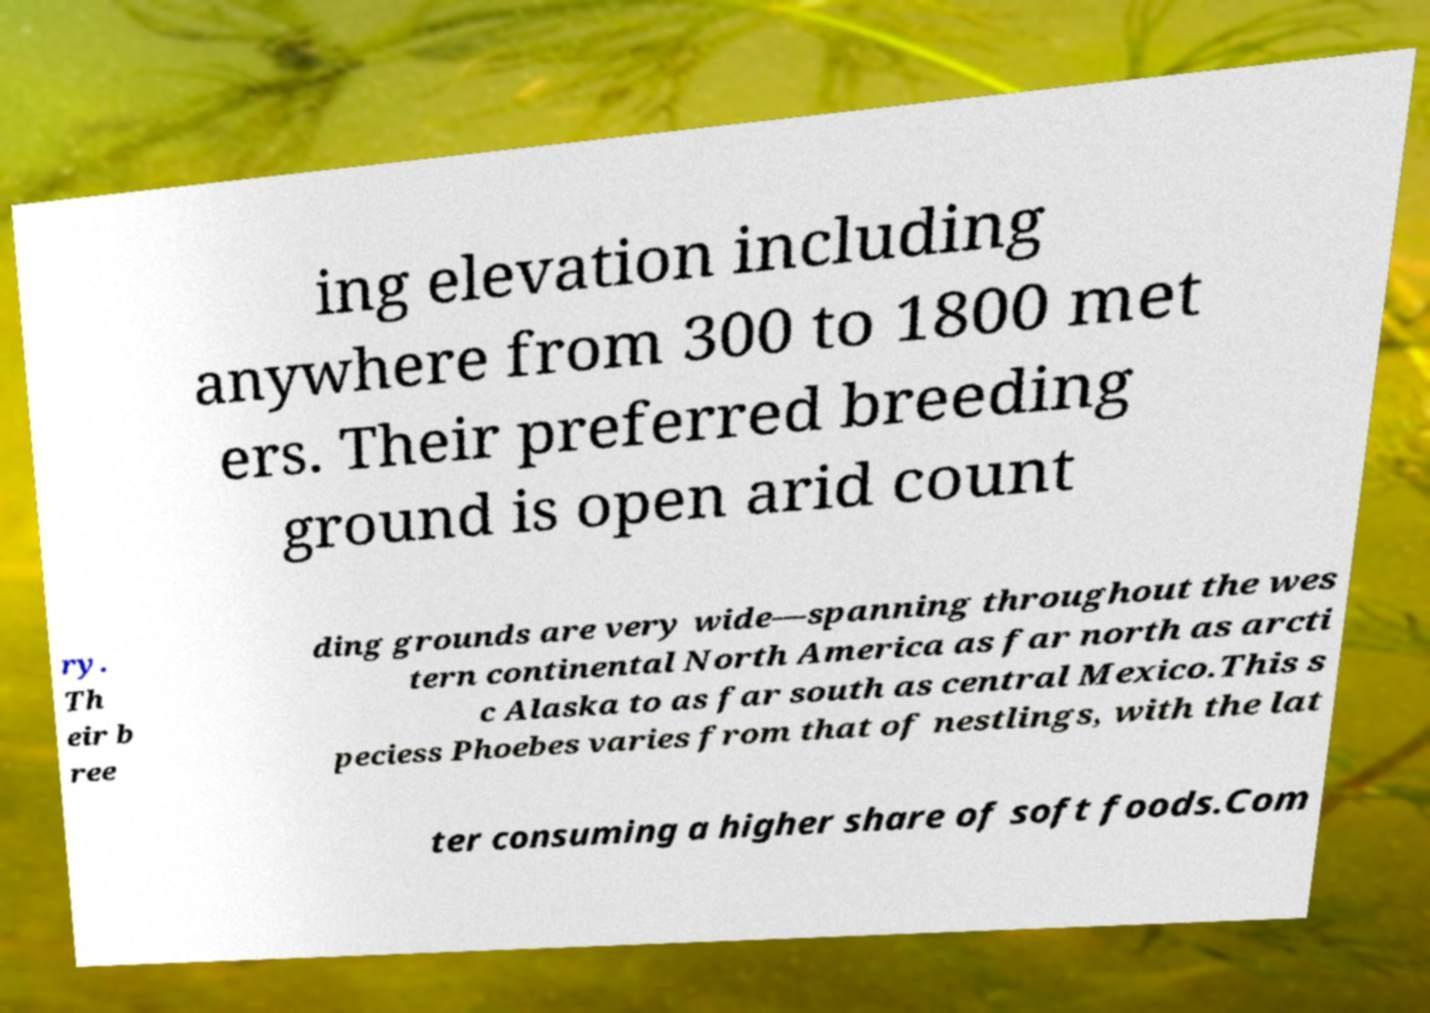There's text embedded in this image that I need extracted. Can you transcribe it verbatim? ing elevation including anywhere from 300 to 1800 met ers. Their preferred breeding ground is open arid count ry. Th eir b ree ding grounds are very wide—spanning throughout the wes tern continental North America as far north as arcti c Alaska to as far south as central Mexico.This s peciess Phoebes varies from that of nestlings, with the lat ter consuming a higher share of soft foods.Com 